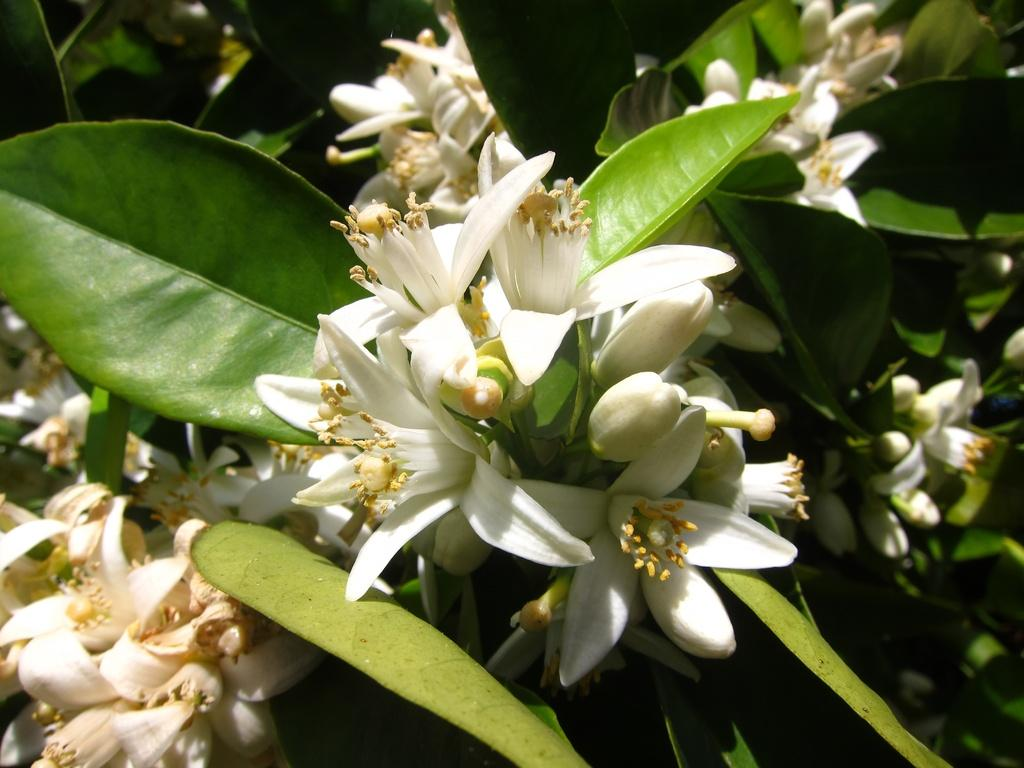What type of flowers are on the plant in the image? There are white color flowers on the plant in the image. Can you describe the plant in the image? The text only mentions that there are white color flowers on a plant, so we cannot describe the plant in detail. What type of seafood is being served by the expert in the image? There is no mention of an expert or seafood in the image, so we cannot answer this question. 